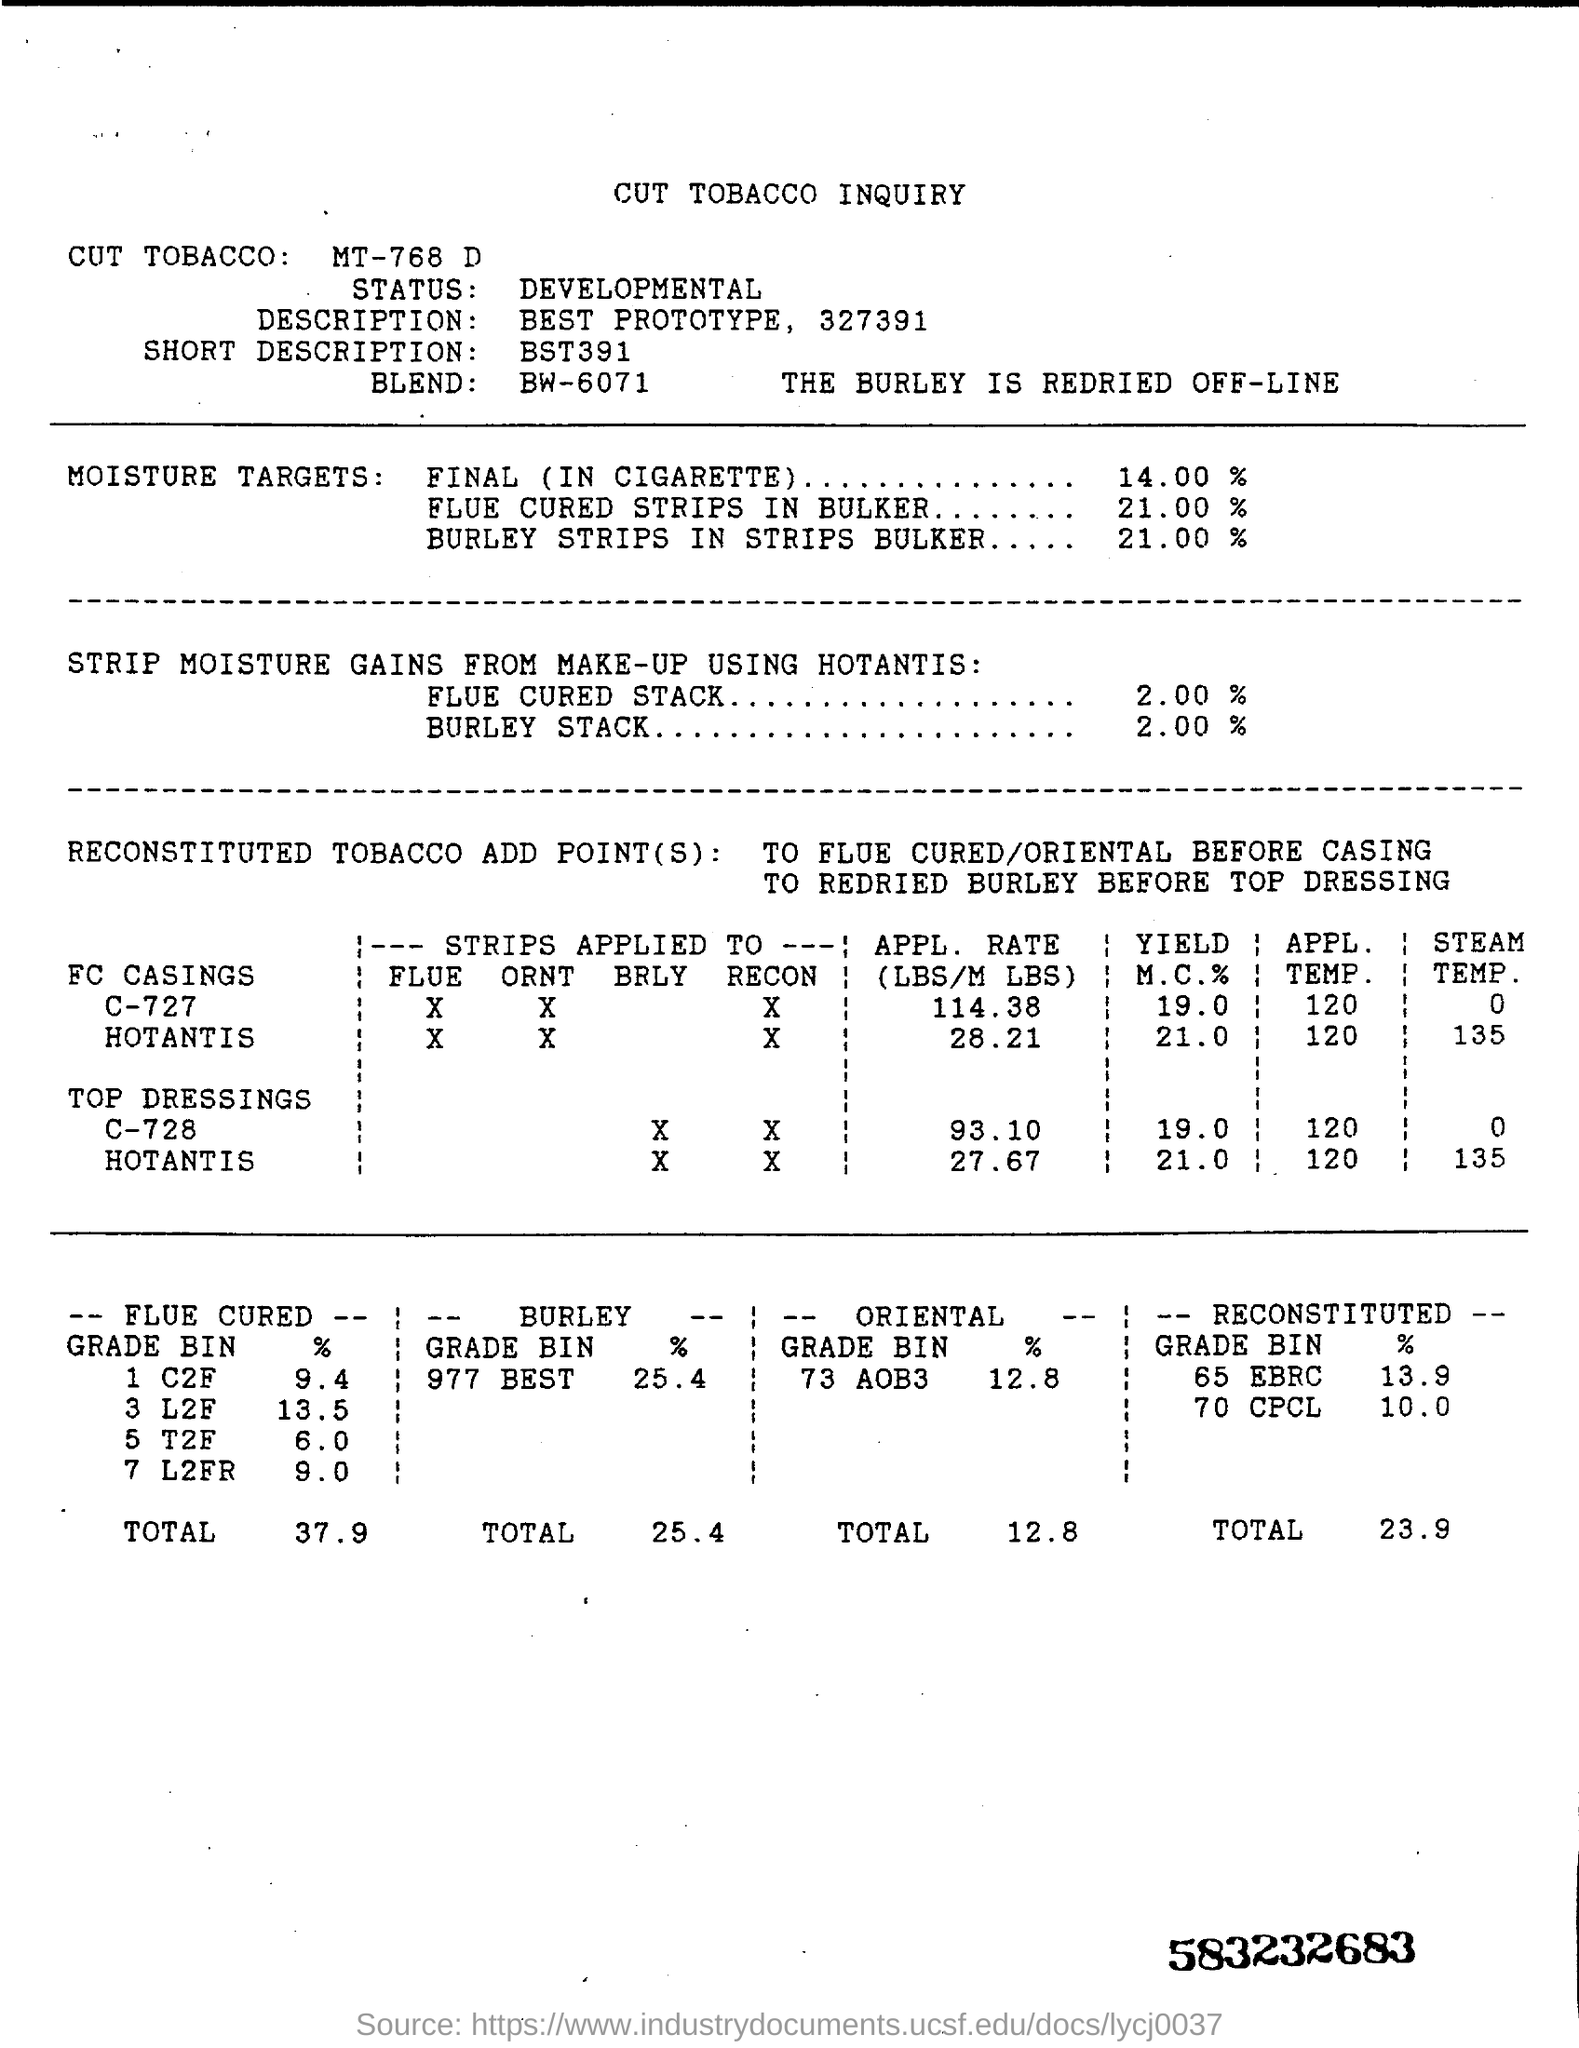Identify some key points in this picture. The document indicates that "flue cured" represents 37.9% of the total. The short description of this document is unknown. The status of this document is developmental. The percentage of moisture targets in cigarettes is 14.00%. The title written on the top of the document is 'cut tobacco inquiry.' 